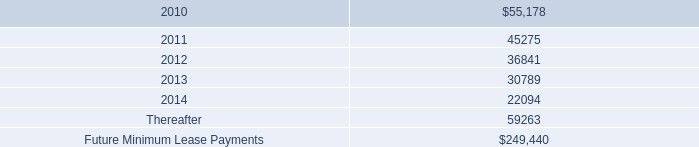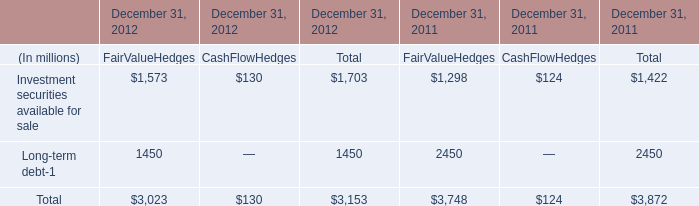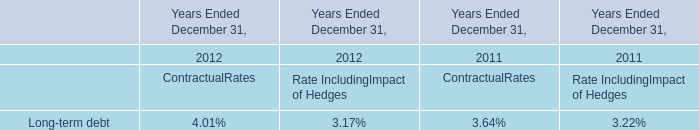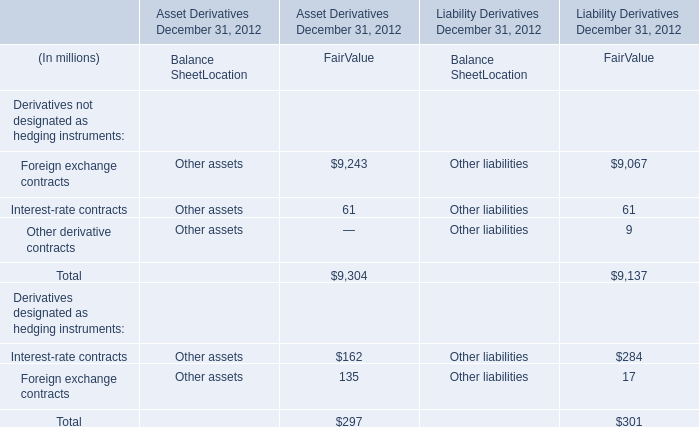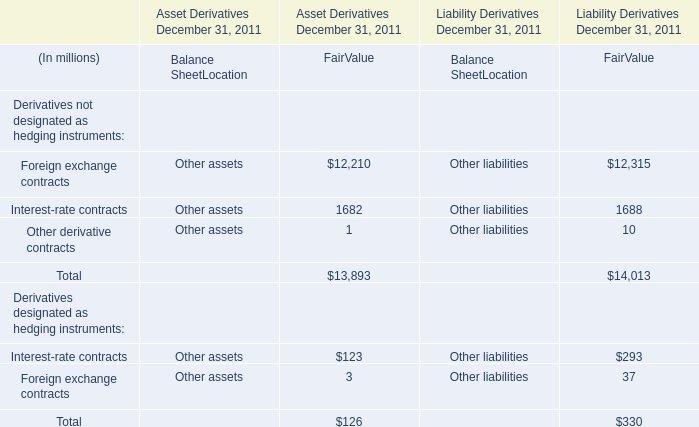what was the percentage change in rental expense for operating leases from 2007 to 2008? 
Computations: ((49.0 - 26.6) / 26.6)
Answer: 0.84211. 